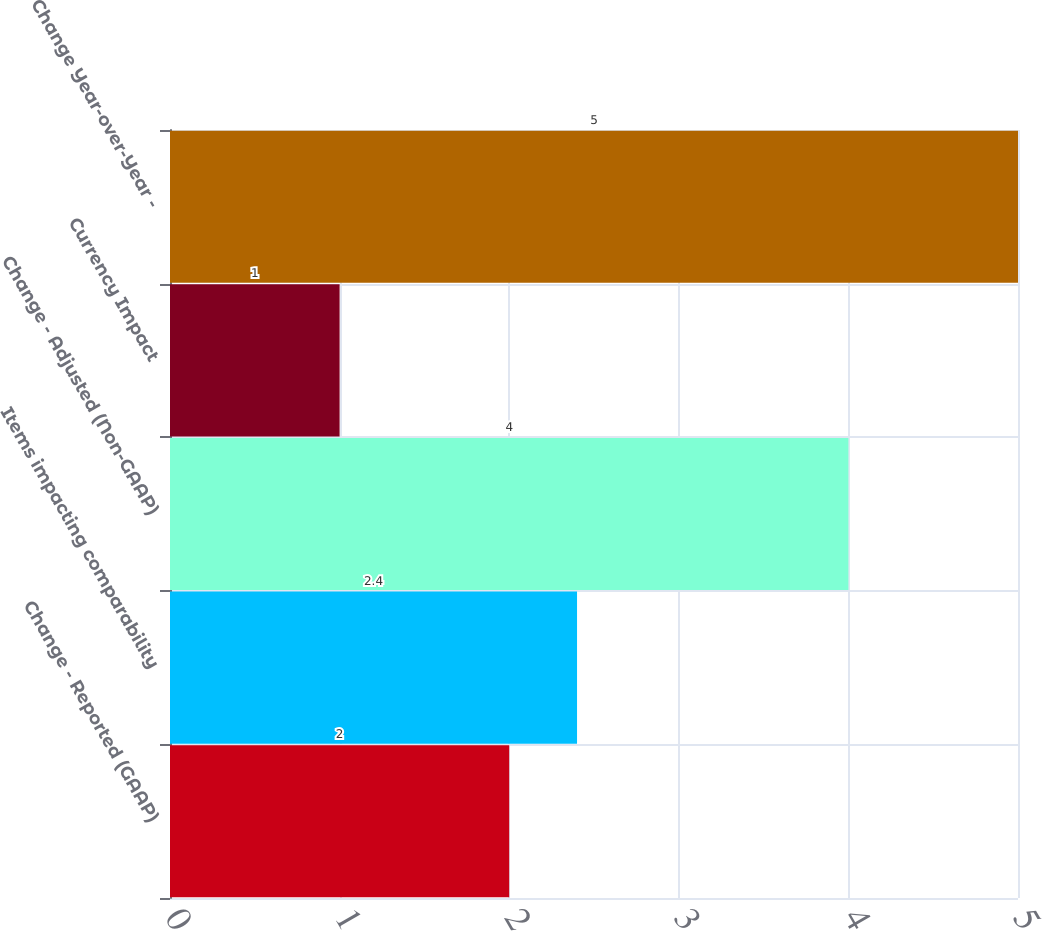Convert chart. <chart><loc_0><loc_0><loc_500><loc_500><bar_chart><fcel>Change - Reported (GAAP)<fcel>Items impacting comparability<fcel>Change - Adjusted (Non-GAAP)<fcel>Currency Impact<fcel>Change Year-over-Year -<nl><fcel>2<fcel>2.4<fcel>4<fcel>1<fcel>5<nl></chart> 